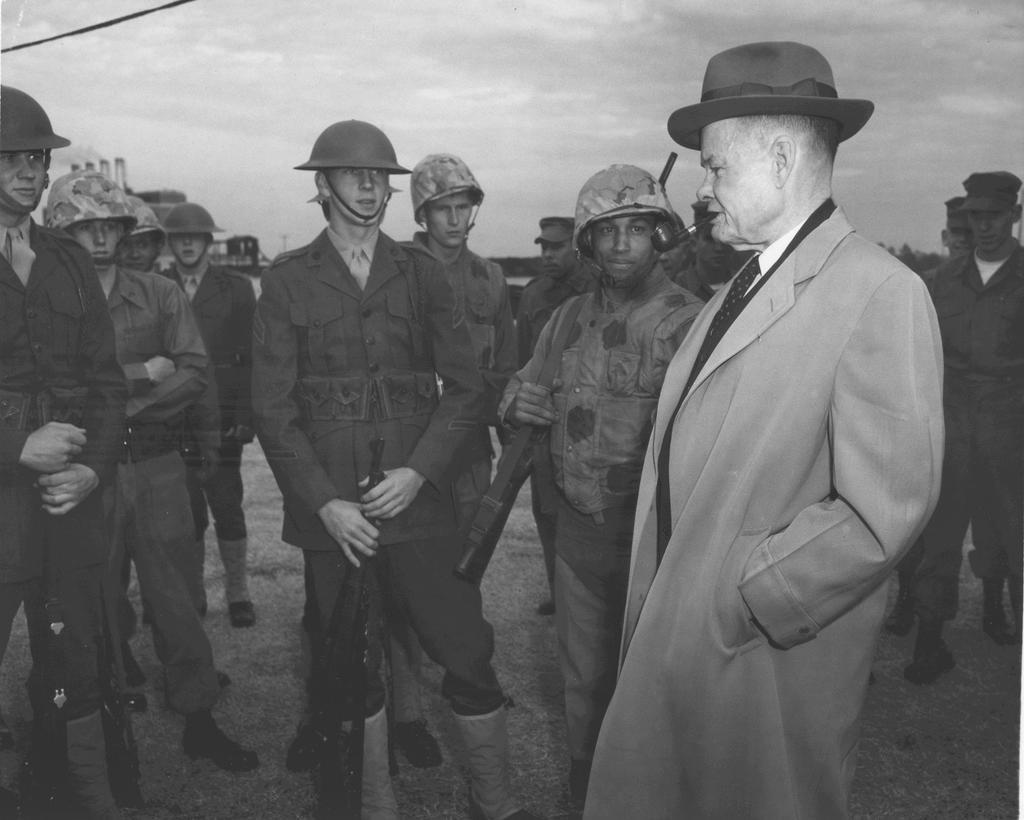What are the corps in the image doing? The corps are standing in the image and holding guns. Can you describe the man on the right side of the image? There is a man on the right side of the image, but no specific details are provided about him. What might the corps be preparing for, given that they are holding guns? It is not possible to determine their intentions from the image alone. What type of kite is the man flying on the right side of the image? There is no kite present in the image; the man is simply standing on the right side. 